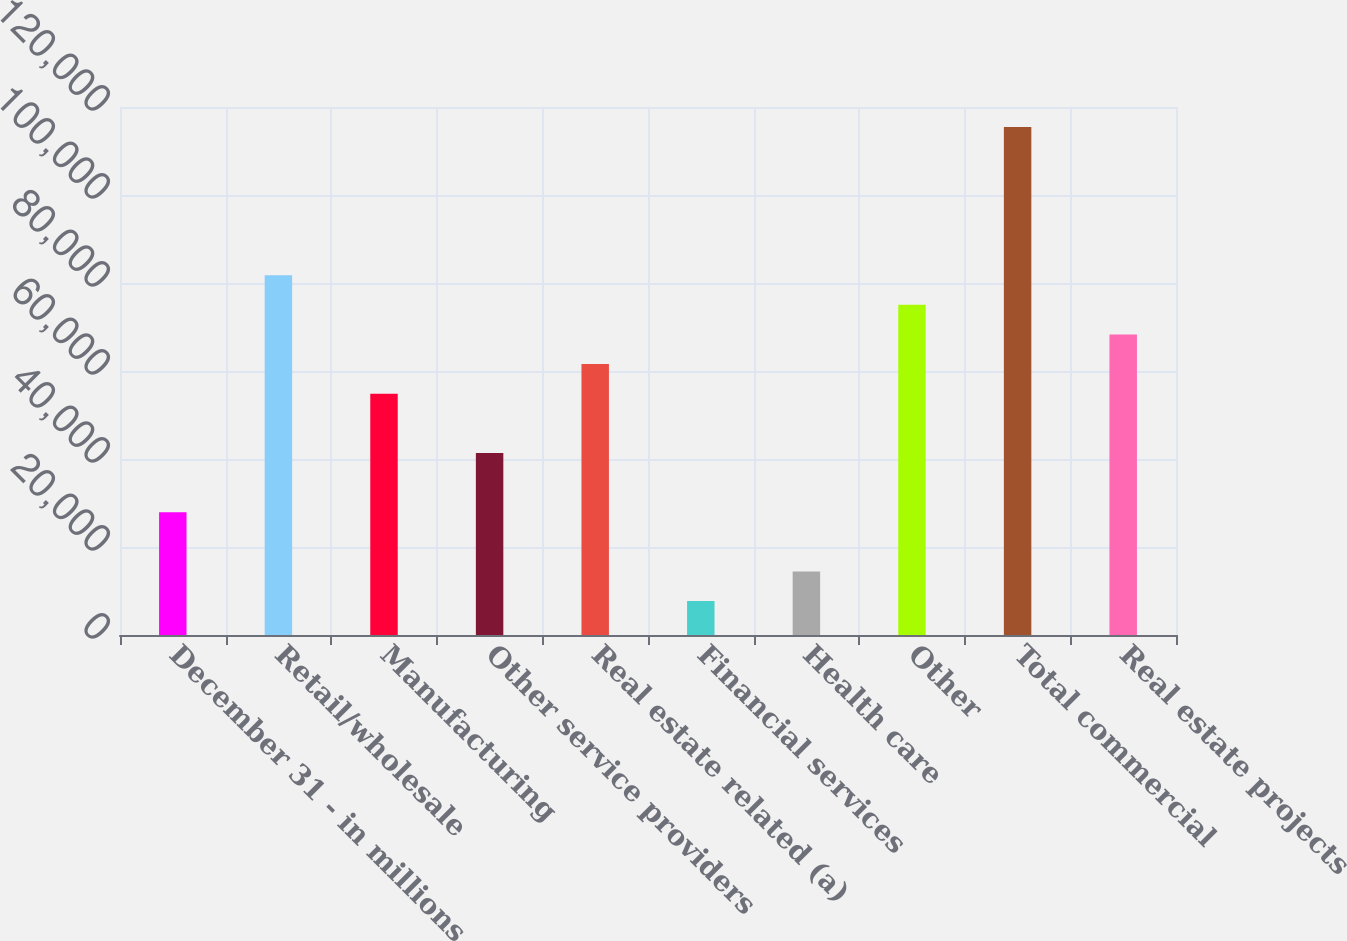<chart> <loc_0><loc_0><loc_500><loc_500><bar_chart><fcel>December 31 - in millions<fcel>Retail/wholesale<fcel>Manufacturing<fcel>Other service providers<fcel>Real estate related (a)<fcel>Financial services<fcel>Health care<fcel>Other<fcel>Total commercial<fcel>Real estate projects<nl><fcel>27921.6<fcel>81784.8<fcel>54853.2<fcel>41387.4<fcel>61586.1<fcel>7722.9<fcel>14455.8<fcel>75051.9<fcel>115449<fcel>68319<nl></chart> 